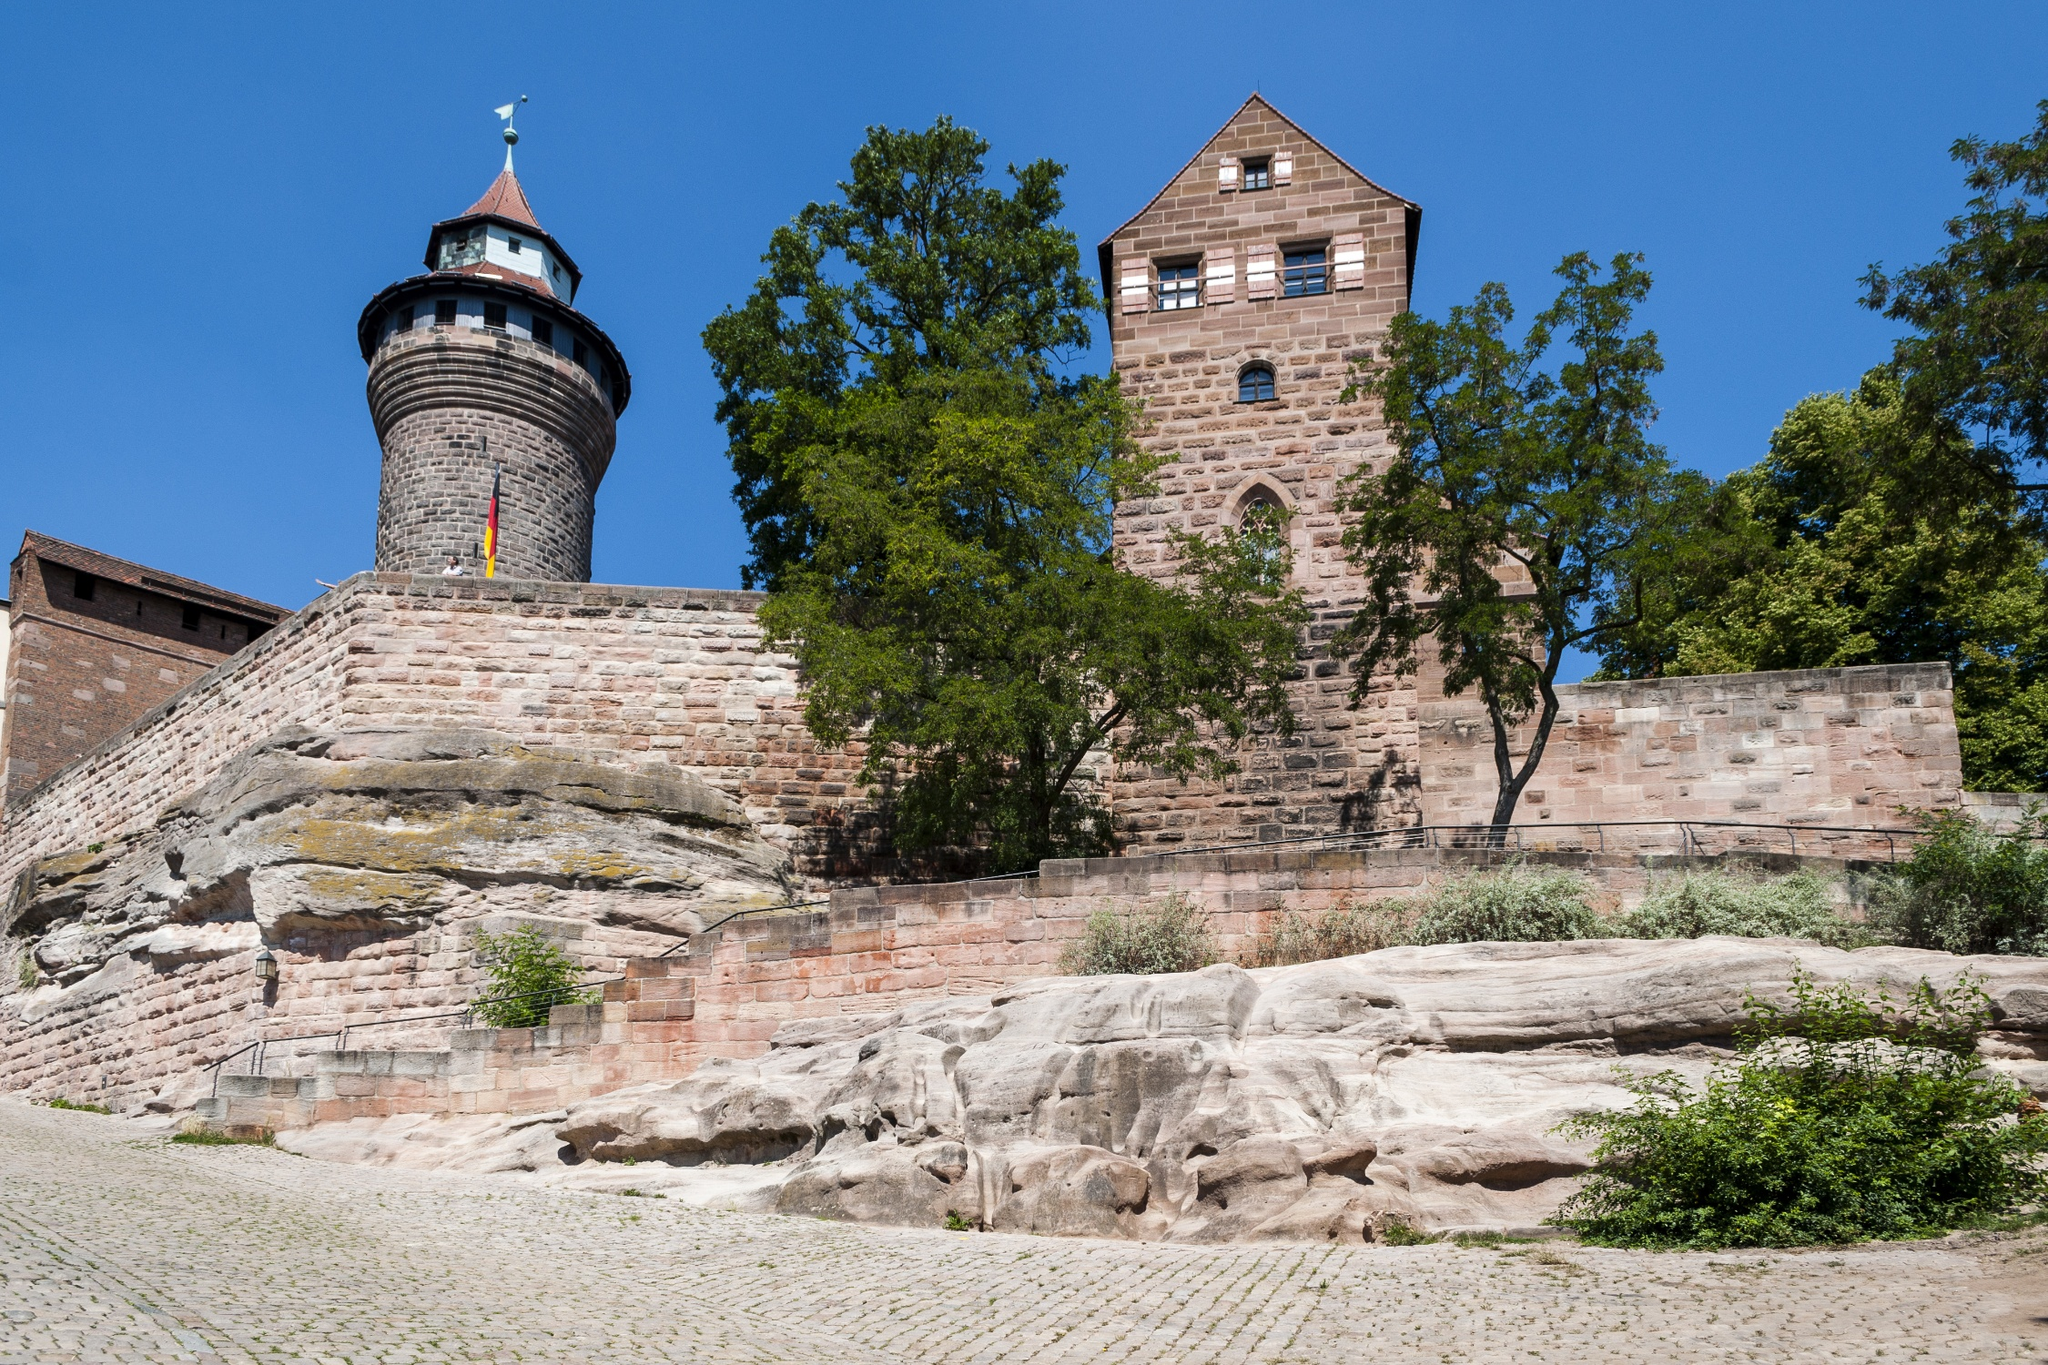Can you elaborate on the elements of the picture provided? The image beautifully captures Kaiserburg Nürnberg, a historically significant castle situated in Nuremberg, Germany. You can see the Sinwell Tower, topped with a lookout turret, and the Walburgis Chapel, both prominent architectural attributes of the castle. These structures are constructed with robust sandstone walls which speak volumes of the medieval architectural capabilities. The castle is positioned on a rugged sandstone outcrop, highlighting its defensive strategic importance in history. The picture also shows the rich green foliage surrounding the castle, contrasting with the stark stonework of the fortifications. This lush greenery not only beautifies the scene but also softens the hard lines of the architectural structures, offering a harmonious blend of nature and human craftsmanship. The clear blue sky in the backdrop sets a serene and tranquil mood, inviting visitors to explore this merger of history and nature. 